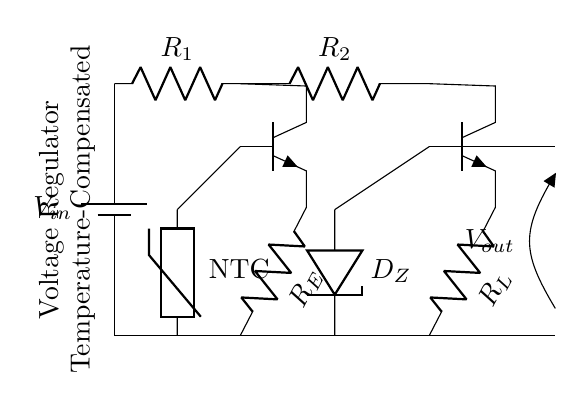What is the input voltage of this circuit? The input voltage is represented by the symbol V_in, which is shown in the circuit as the source connected to the battery symbol on the left side.
Answer: V_in What type of transistors are used in this circuit? The circuit diagram includes two transistor symbols marked as npn, indicating that both transistors are of the NPN type.
Answer: NPN How many resistors are present in the circuit? The circuit contains three resistors: R_1, R_2, and R_E, which can be identified by their respective labels and positions in the diagram.
Answer: Three What is the purpose of the thermistor in this circuit? The thermistor, marked as NTC, is a temperature-dependent resistor that helps maintain voltage stability by compensating for temperature variations.
Answer: Temperature compensation How does the Zener diode function in this circuit? The Zener diode, labeled as D_Z, is used to regulate the output voltage to maintain a stable voltage level despite changes in input voltage and temperature conditions.
Answer: Voltage regulation What happens to the output voltage if the temperature increases? If the temperature increases, the resistance of the thermistor decreases, which in turn affects the biasing of the transistors, leading to a modified output voltage to maintain stability.
Answer: Output voltage changes What is the output voltage of the regulator denoted as? The output voltage in the circuit is represented as V_out, which is indicated by the label next to the open terminal on the right side of the circuit diagram.
Answer: V_out 